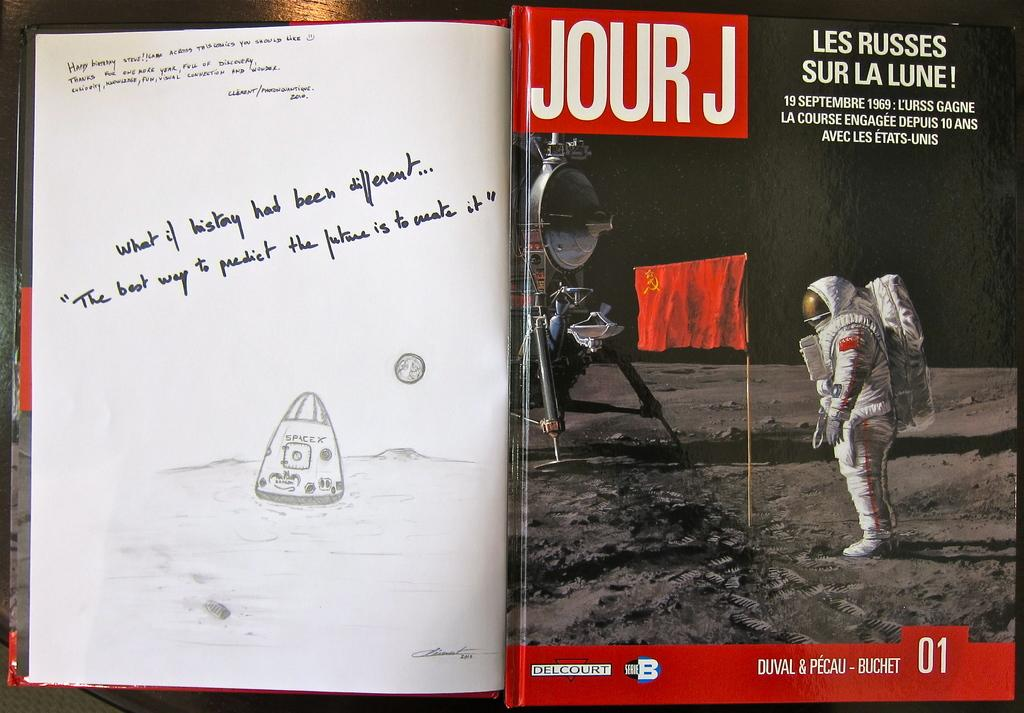<image>
Provide a brief description of the given image. Foreign language 'Life,' vintage magazine cover the when Neil Armstrong put a flag on the moon as an illustration and writing is to the left. 